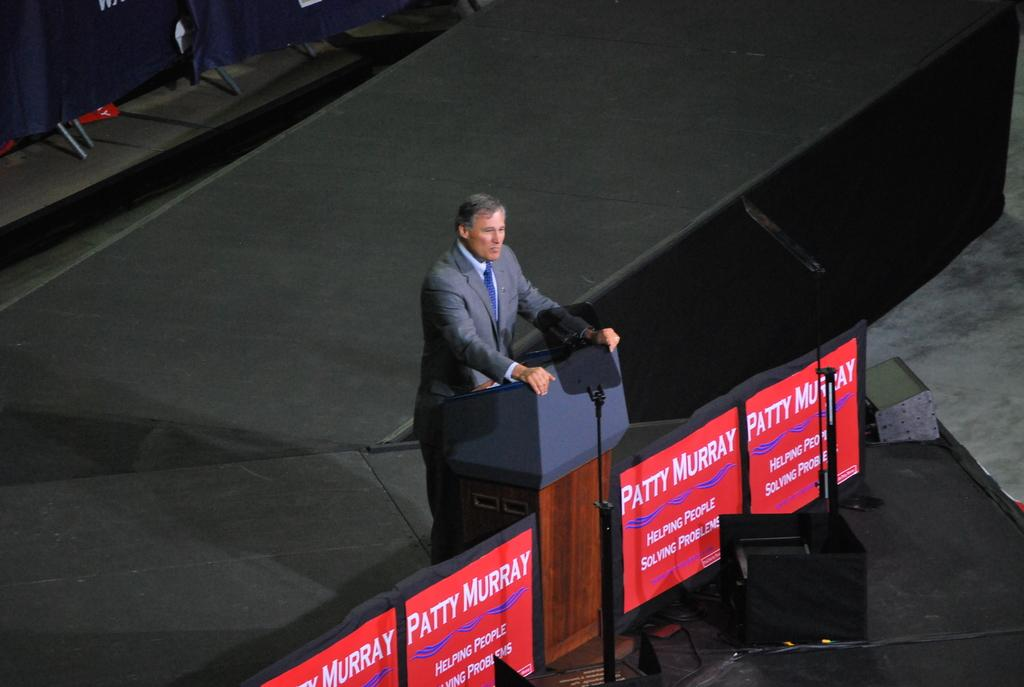Who is the main subject in the image? There is a man standing in the center of the image. What is the man standing in front of? There is a podium before the man. Who else can be seen in the image? There is a speaker on the right side of the image. What type of surface is visible at the bottom of the image? There is a carpet at the bottom of the image. What objects are visible on the boards in the image? The provided facts do not mention any specific objects on the boards, so we cannot answer that question definitively. How many friends does the man have in the image? The provided facts do not mention any friends in the image, so we cannot answer that question definitively. What type of finger is the man using to point at the speaker in the image? There is no indication in the image that the man is pointing at the speaker, so we cannot answer that question definitively. 